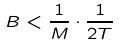Convert formula to latex. <formula><loc_0><loc_0><loc_500><loc_500>B < \frac { 1 } { M } \cdot \frac { 1 } { 2 T }</formula> 